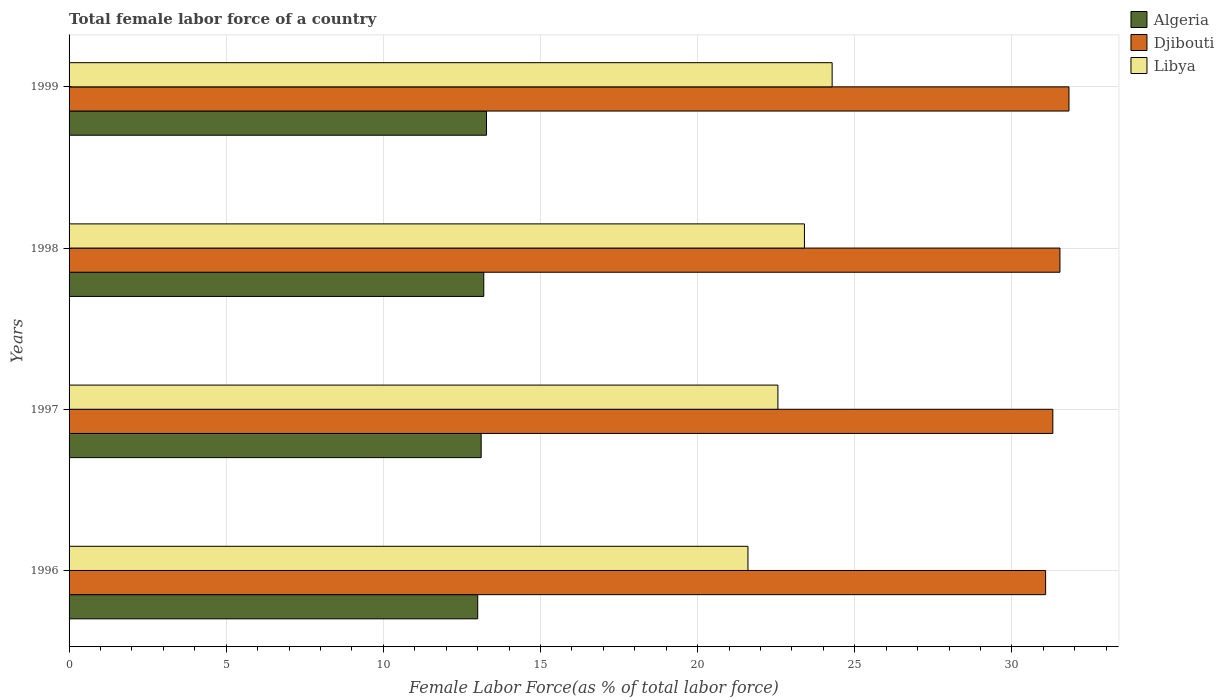Are the number of bars per tick equal to the number of legend labels?
Ensure brevity in your answer.  Yes. How many bars are there on the 1st tick from the top?
Provide a succinct answer. 3. How many bars are there on the 4th tick from the bottom?
Ensure brevity in your answer.  3. What is the percentage of female labor force in Libya in 1997?
Your answer should be compact. 22.55. Across all years, what is the maximum percentage of female labor force in Djibouti?
Your response must be concise. 31.81. Across all years, what is the minimum percentage of female labor force in Djibouti?
Offer a terse response. 31.07. In which year was the percentage of female labor force in Algeria maximum?
Provide a short and direct response. 1999. What is the total percentage of female labor force in Djibouti in the graph?
Offer a very short reply. 125.71. What is the difference between the percentage of female labor force in Algeria in 1997 and that in 1998?
Your answer should be very brief. -0.08. What is the difference between the percentage of female labor force in Djibouti in 1996 and the percentage of female labor force in Algeria in 1997?
Give a very brief answer. 17.96. What is the average percentage of female labor force in Libya per year?
Your response must be concise. 22.96. In the year 1998, what is the difference between the percentage of female labor force in Libya and percentage of female labor force in Algeria?
Your answer should be compact. 10.2. What is the ratio of the percentage of female labor force in Djibouti in 1996 to that in 1997?
Offer a very short reply. 0.99. Is the percentage of female labor force in Algeria in 1998 less than that in 1999?
Offer a terse response. Yes. Is the difference between the percentage of female labor force in Libya in 1997 and 1998 greater than the difference between the percentage of female labor force in Algeria in 1997 and 1998?
Give a very brief answer. No. What is the difference between the highest and the second highest percentage of female labor force in Algeria?
Offer a very short reply. 0.09. What is the difference between the highest and the lowest percentage of female labor force in Djibouti?
Offer a very short reply. 0.74. Is the sum of the percentage of female labor force in Libya in 1998 and 1999 greater than the maximum percentage of female labor force in Djibouti across all years?
Offer a terse response. Yes. What does the 2nd bar from the top in 1999 represents?
Provide a short and direct response. Djibouti. What does the 1st bar from the bottom in 1997 represents?
Make the answer very short. Algeria. Is it the case that in every year, the sum of the percentage of female labor force in Libya and percentage of female labor force in Djibouti is greater than the percentage of female labor force in Algeria?
Your answer should be compact. Yes. Are all the bars in the graph horizontal?
Give a very brief answer. Yes. What is the difference between two consecutive major ticks on the X-axis?
Keep it short and to the point. 5. Does the graph contain grids?
Give a very brief answer. Yes. Where does the legend appear in the graph?
Offer a very short reply. Top right. What is the title of the graph?
Offer a terse response. Total female labor force of a country. Does "Malta" appear as one of the legend labels in the graph?
Offer a terse response. No. What is the label or title of the X-axis?
Provide a succinct answer. Female Labor Force(as % of total labor force). What is the Female Labor Force(as % of total labor force) of Algeria in 1996?
Ensure brevity in your answer.  13. What is the Female Labor Force(as % of total labor force) of Djibouti in 1996?
Your answer should be very brief. 31.07. What is the Female Labor Force(as % of total labor force) in Libya in 1996?
Offer a very short reply. 21.6. What is the Female Labor Force(as % of total labor force) in Algeria in 1997?
Provide a succinct answer. 13.11. What is the Female Labor Force(as % of total labor force) of Djibouti in 1997?
Your answer should be very brief. 31.3. What is the Female Labor Force(as % of total labor force) in Libya in 1997?
Make the answer very short. 22.55. What is the Female Labor Force(as % of total labor force) of Algeria in 1998?
Offer a very short reply. 13.19. What is the Female Labor Force(as % of total labor force) of Djibouti in 1998?
Your response must be concise. 31.53. What is the Female Labor Force(as % of total labor force) in Libya in 1998?
Your answer should be very brief. 23.4. What is the Female Labor Force(as % of total labor force) in Algeria in 1999?
Ensure brevity in your answer.  13.28. What is the Female Labor Force(as % of total labor force) in Djibouti in 1999?
Provide a succinct answer. 31.81. What is the Female Labor Force(as % of total labor force) in Libya in 1999?
Your answer should be very brief. 24.28. Across all years, what is the maximum Female Labor Force(as % of total labor force) of Algeria?
Your response must be concise. 13.28. Across all years, what is the maximum Female Labor Force(as % of total labor force) in Djibouti?
Provide a short and direct response. 31.81. Across all years, what is the maximum Female Labor Force(as % of total labor force) in Libya?
Provide a short and direct response. 24.28. Across all years, what is the minimum Female Labor Force(as % of total labor force) of Algeria?
Your answer should be compact. 13. Across all years, what is the minimum Female Labor Force(as % of total labor force) of Djibouti?
Your answer should be compact. 31.07. Across all years, what is the minimum Female Labor Force(as % of total labor force) in Libya?
Provide a succinct answer. 21.6. What is the total Female Labor Force(as % of total labor force) in Algeria in the graph?
Make the answer very short. 52.59. What is the total Female Labor Force(as % of total labor force) of Djibouti in the graph?
Your answer should be very brief. 125.71. What is the total Female Labor Force(as % of total labor force) of Libya in the graph?
Your answer should be compact. 91.83. What is the difference between the Female Labor Force(as % of total labor force) in Algeria in 1996 and that in 1997?
Your answer should be compact. -0.11. What is the difference between the Female Labor Force(as % of total labor force) of Djibouti in 1996 and that in 1997?
Your response must be concise. -0.23. What is the difference between the Female Labor Force(as % of total labor force) of Libya in 1996 and that in 1997?
Make the answer very short. -0.95. What is the difference between the Female Labor Force(as % of total labor force) in Algeria in 1996 and that in 1998?
Ensure brevity in your answer.  -0.19. What is the difference between the Female Labor Force(as % of total labor force) in Djibouti in 1996 and that in 1998?
Your response must be concise. -0.46. What is the difference between the Female Labor Force(as % of total labor force) in Libya in 1996 and that in 1998?
Ensure brevity in your answer.  -1.8. What is the difference between the Female Labor Force(as % of total labor force) in Algeria in 1996 and that in 1999?
Keep it short and to the point. -0.28. What is the difference between the Female Labor Force(as % of total labor force) in Djibouti in 1996 and that in 1999?
Offer a terse response. -0.74. What is the difference between the Female Labor Force(as % of total labor force) of Libya in 1996 and that in 1999?
Your answer should be compact. -2.68. What is the difference between the Female Labor Force(as % of total labor force) of Algeria in 1997 and that in 1998?
Keep it short and to the point. -0.08. What is the difference between the Female Labor Force(as % of total labor force) of Djibouti in 1997 and that in 1998?
Provide a short and direct response. -0.23. What is the difference between the Female Labor Force(as % of total labor force) of Libya in 1997 and that in 1998?
Provide a short and direct response. -0.84. What is the difference between the Female Labor Force(as % of total labor force) in Algeria in 1997 and that in 1999?
Ensure brevity in your answer.  -0.17. What is the difference between the Female Labor Force(as % of total labor force) in Djibouti in 1997 and that in 1999?
Make the answer very short. -0.51. What is the difference between the Female Labor Force(as % of total labor force) of Libya in 1997 and that in 1999?
Provide a succinct answer. -1.73. What is the difference between the Female Labor Force(as % of total labor force) in Algeria in 1998 and that in 1999?
Ensure brevity in your answer.  -0.09. What is the difference between the Female Labor Force(as % of total labor force) of Djibouti in 1998 and that in 1999?
Your response must be concise. -0.29. What is the difference between the Female Labor Force(as % of total labor force) in Libya in 1998 and that in 1999?
Ensure brevity in your answer.  -0.88. What is the difference between the Female Labor Force(as % of total labor force) of Algeria in 1996 and the Female Labor Force(as % of total labor force) of Djibouti in 1997?
Your response must be concise. -18.3. What is the difference between the Female Labor Force(as % of total labor force) in Algeria in 1996 and the Female Labor Force(as % of total labor force) in Libya in 1997?
Keep it short and to the point. -9.55. What is the difference between the Female Labor Force(as % of total labor force) of Djibouti in 1996 and the Female Labor Force(as % of total labor force) of Libya in 1997?
Your answer should be very brief. 8.52. What is the difference between the Female Labor Force(as % of total labor force) of Algeria in 1996 and the Female Labor Force(as % of total labor force) of Djibouti in 1998?
Your answer should be very brief. -18.52. What is the difference between the Female Labor Force(as % of total labor force) of Algeria in 1996 and the Female Labor Force(as % of total labor force) of Libya in 1998?
Ensure brevity in your answer.  -10.4. What is the difference between the Female Labor Force(as % of total labor force) of Djibouti in 1996 and the Female Labor Force(as % of total labor force) of Libya in 1998?
Offer a terse response. 7.67. What is the difference between the Female Labor Force(as % of total labor force) in Algeria in 1996 and the Female Labor Force(as % of total labor force) in Djibouti in 1999?
Make the answer very short. -18.81. What is the difference between the Female Labor Force(as % of total labor force) of Algeria in 1996 and the Female Labor Force(as % of total labor force) of Libya in 1999?
Your answer should be very brief. -11.28. What is the difference between the Female Labor Force(as % of total labor force) in Djibouti in 1996 and the Female Labor Force(as % of total labor force) in Libya in 1999?
Your answer should be compact. 6.79. What is the difference between the Female Labor Force(as % of total labor force) of Algeria in 1997 and the Female Labor Force(as % of total labor force) of Djibouti in 1998?
Ensure brevity in your answer.  -18.41. What is the difference between the Female Labor Force(as % of total labor force) in Algeria in 1997 and the Female Labor Force(as % of total labor force) in Libya in 1998?
Ensure brevity in your answer.  -10.29. What is the difference between the Female Labor Force(as % of total labor force) in Djibouti in 1997 and the Female Labor Force(as % of total labor force) in Libya in 1998?
Offer a terse response. 7.9. What is the difference between the Female Labor Force(as % of total labor force) of Algeria in 1997 and the Female Labor Force(as % of total labor force) of Djibouti in 1999?
Your answer should be very brief. -18.7. What is the difference between the Female Labor Force(as % of total labor force) in Algeria in 1997 and the Female Labor Force(as % of total labor force) in Libya in 1999?
Your answer should be compact. -11.17. What is the difference between the Female Labor Force(as % of total labor force) in Djibouti in 1997 and the Female Labor Force(as % of total labor force) in Libya in 1999?
Your answer should be very brief. 7.02. What is the difference between the Female Labor Force(as % of total labor force) in Algeria in 1998 and the Female Labor Force(as % of total labor force) in Djibouti in 1999?
Keep it short and to the point. -18.62. What is the difference between the Female Labor Force(as % of total labor force) of Algeria in 1998 and the Female Labor Force(as % of total labor force) of Libya in 1999?
Offer a terse response. -11.08. What is the difference between the Female Labor Force(as % of total labor force) of Djibouti in 1998 and the Female Labor Force(as % of total labor force) of Libya in 1999?
Keep it short and to the point. 7.25. What is the average Female Labor Force(as % of total labor force) of Algeria per year?
Your response must be concise. 13.15. What is the average Female Labor Force(as % of total labor force) of Djibouti per year?
Your answer should be very brief. 31.43. What is the average Female Labor Force(as % of total labor force) of Libya per year?
Ensure brevity in your answer.  22.96. In the year 1996, what is the difference between the Female Labor Force(as % of total labor force) in Algeria and Female Labor Force(as % of total labor force) in Djibouti?
Give a very brief answer. -18.07. In the year 1996, what is the difference between the Female Labor Force(as % of total labor force) of Algeria and Female Labor Force(as % of total labor force) of Libya?
Make the answer very short. -8.6. In the year 1996, what is the difference between the Female Labor Force(as % of total labor force) of Djibouti and Female Labor Force(as % of total labor force) of Libya?
Ensure brevity in your answer.  9.47. In the year 1997, what is the difference between the Female Labor Force(as % of total labor force) of Algeria and Female Labor Force(as % of total labor force) of Djibouti?
Keep it short and to the point. -18.19. In the year 1997, what is the difference between the Female Labor Force(as % of total labor force) in Algeria and Female Labor Force(as % of total labor force) in Libya?
Your response must be concise. -9.44. In the year 1997, what is the difference between the Female Labor Force(as % of total labor force) in Djibouti and Female Labor Force(as % of total labor force) in Libya?
Keep it short and to the point. 8.75. In the year 1998, what is the difference between the Female Labor Force(as % of total labor force) in Algeria and Female Labor Force(as % of total labor force) in Djibouti?
Your answer should be very brief. -18.33. In the year 1998, what is the difference between the Female Labor Force(as % of total labor force) of Algeria and Female Labor Force(as % of total labor force) of Libya?
Your response must be concise. -10.2. In the year 1998, what is the difference between the Female Labor Force(as % of total labor force) of Djibouti and Female Labor Force(as % of total labor force) of Libya?
Your answer should be compact. 8.13. In the year 1999, what is the difference between the Female Labor Force(as % of total labor force) in Algeria and Female Labor Force(as % of total labor force) in Djibouti?
Make the answer very short. -18.53. In the year 1999, what is the difference between the Female Labor Force(as % of total labor force) in Algeria and Female Labor Force(as % of total labor force) in Libya?
Provide a succinct answer. -11. In the year 1999, what is the difference between the Female Labor Force(as % of total labor force) of Djibouti and Female Labor Force(as % of total labor force) of Libya?
Your answer should be very brief. 7.53. What is the ratio of the Female Labor Force(as % of total labor force) of Algeria in 1996 to that in 1997?
Give a very brief answer. 0.99. What is the ratio of the Female Labor Force(as % of total labor force) in Libya in 1996 to that in 1997?
Offer a very short reply. 0.96. What is the ratio of the Female Labor Force(as % of total labor force) in Algeria in 1996 to that in 1998?
Your answer should be compact. 0.99. What is the ratio of the Female Labor Force(as % of total labor force) of Djibouti in 1996 to that in 1998?
Provide a succinct answer. 0.99. What is the ratio of the Female Labor Force(as % of total labor force) of Libya in 1996 to that in 1998?
Your response must be concise. 0.92. What is the ratio of the Female Labor Force(as % of total labor force) of Algeria in 1996 to that in 1999?
Provide a short and direct response. 0.98. What is the ratio of the Female Labor Force(as % of total labor force) of Djibouti in 1996 to that in 1999?
Provide a short and direct response. 0.98. What is the ratio of the Female Labor Force(as % of total labor force) in Libya in 1996 to that in 1999?
Make the answer very short. 0.89. What is the ratio of the Female Labor Force(as % of total labor force) in Algeria in 1997 to that in 1998?
Give a very brief answer. 0.99. What is the ratio of the Female Labor Force(as % of total labor force) in Djibouti in 1997 to that in 1998?
Provide a short and direct response. 0.99. What is the ratio of the Female Labor Force(as % of total labor force) of Libya in 1997 to that in 1998?
Your response must be concise. 0.96. What is the ratio of the Female Labor Force(as % of total labor force) in Algeria in 1997 to that in 1999?
Give a very brief answer. 0.99. What is the ratio of the Female Labor Force(as % of total labor force) of Djibouti in 1997 to that in 1999?
Your response must be concise. 0.98. What is the ratio of the Female Labor Force(as % of total labor force) of Libya in 1997 to that in 1999?
Provide a short and direct response. 0.93. What is the ratio of the Female Labor Force(as % of total labor force) in Libya in 1998 to that in 1999?
Make the answer very short. 0.96. What is the difference between the highest and the second highest Female Labor Force(as % of total labor force) of Algeria?
Provide a short and direct response. 0.09. What is the difference between the highest and the second highest Female Labor Force(as % of total labor force) in Djibouti?
Offer a very short reply. 0.29. What is the difference between the highest and the second highest Female Labor Force(as % of total labor force) in Libya?
Make the answer very short. 0.88. What is the difference between the highest and the lowest Female Labor Force(as % of total labor force) of Algeria?
Keep it short and to the point. 0.28. What is the difference between the highest and the lowest Female Labor Force(as % of total labor force) in Djibouti?
Your answer should be compact. 0.74. What is the difference between the highest and the lowest Female Labor Force(as % of total labor force) in Libya?
Keep it short and to the point. 2.68. 